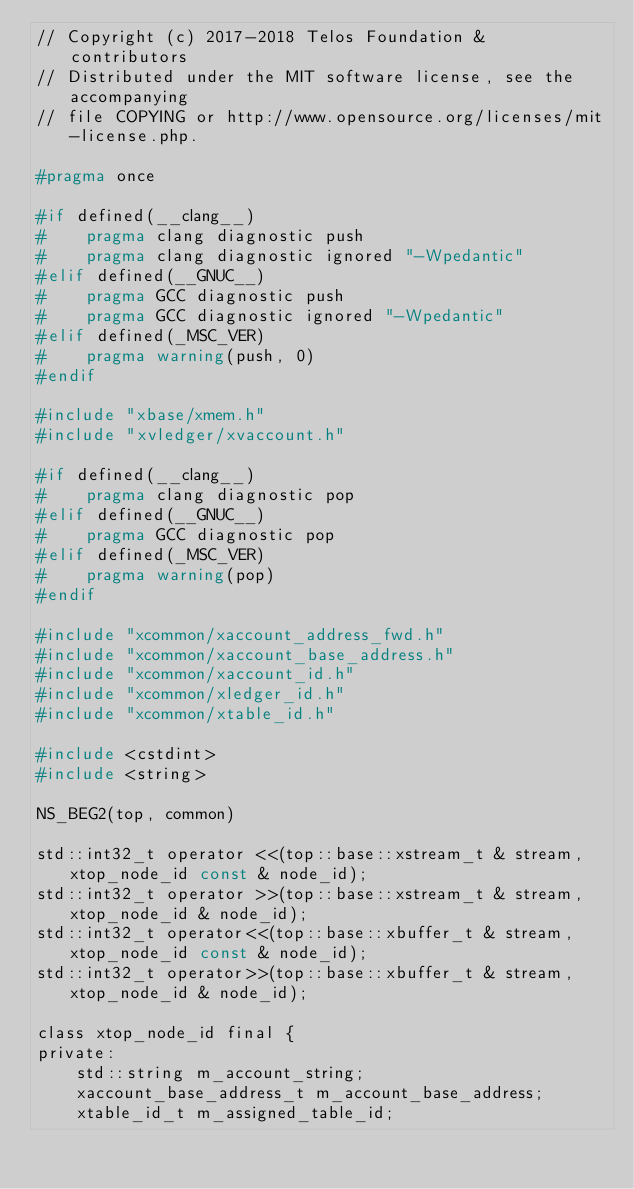<code> <loc_0><loc_0><loc_500><loc_500><_C_>// Copyright (c) 2017-2018 Telos Foundation & contributors
// Distributed under the MIT software license, see the accompanying
// file COPYING or http://www.opensource.org/licenses/mit-license.php.

#pragma once

#if defined(__clang__)
#    pragma clang diagnostic push
#    pragma clang diagnostic ignored "-Wpedantic"
#elif defined(__GNUC__)
#    pragma GCC diagnostic push
#    pragma GCC diagnostic ignored "-Wpedantic"
#elif defined(_MSC_VER)
#    pragma warning(push, 0)
#endif

#include "xbase/xmem.h"
#include "xvledger/xvaccount.h"

#if defined(__clang__)
#    pragma clang diagnostic pop
#elif defined(__GNUC__)
#    pragma GCC diagnostic pop
#elif defined(_MSC_VER)
#    pragma warning(pop)
#endif

#include "xcommon/xaccount_address_fwd.h"
#include "xcommon/xaccount_base_address.h"
#include "xcommon/xaccount_id.h"
#include "xcommon/xledger_id.h"
#include "xcommon/xtable_id.h"

#include <cstdint>
#include <string>

NS_BEG2(top, common)

std::int32_t operator <<(top::base::xstream_t & stream, xtop_node_id const & node_id);
std::int32_t operator >>(top::base::xstream_t & stream, xtop_node_id & node_id);
std::int32_t operator<<(top::base::xbuffer_t & stream, xtop_node_id const & node_id);
std::int32_t operator>>(top::base::xbuffer_t & stream, xtop_node_id & node_id);

class xtop_node_id final {
private:
    std::string m_account_string;
    xaccount_base_address_t m_account_base_address;
    xtable_id_t m_assigned_table_id;
</code> 